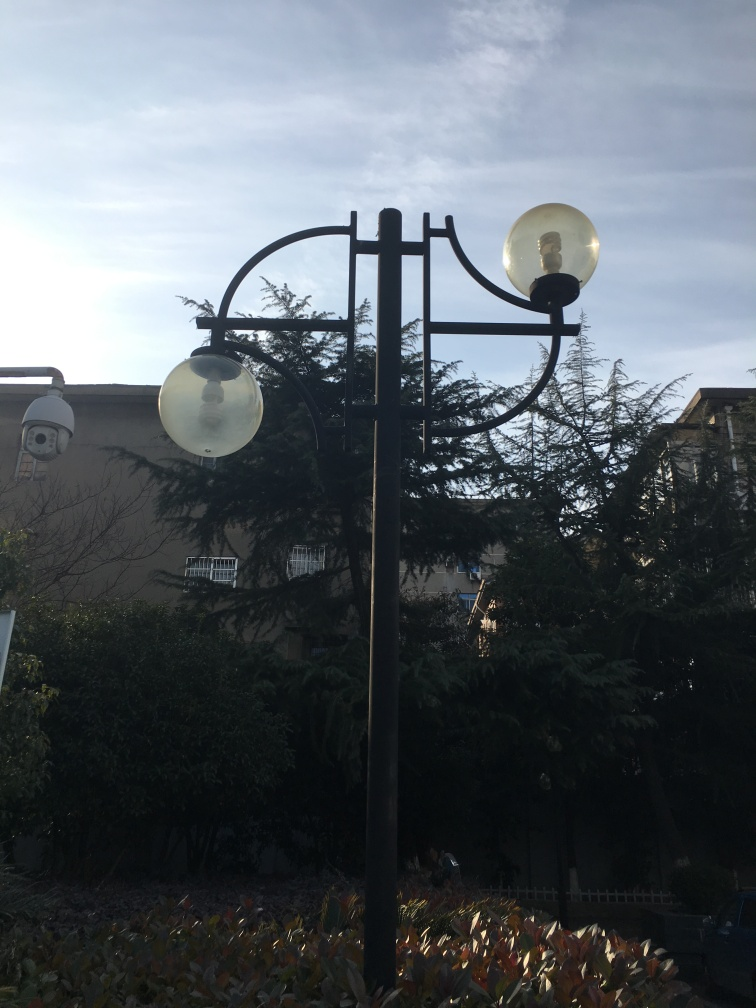What is the average focus of the image?
A. crystal clear
B. blurred
C. average
D. sharp The focus of the image can be considered 'C. average' because while the main elements such as the streetlamp and foliage are discernible, there is a softness around the edges and a lack of sharp detail that might be considered crystal clear or sharp. 